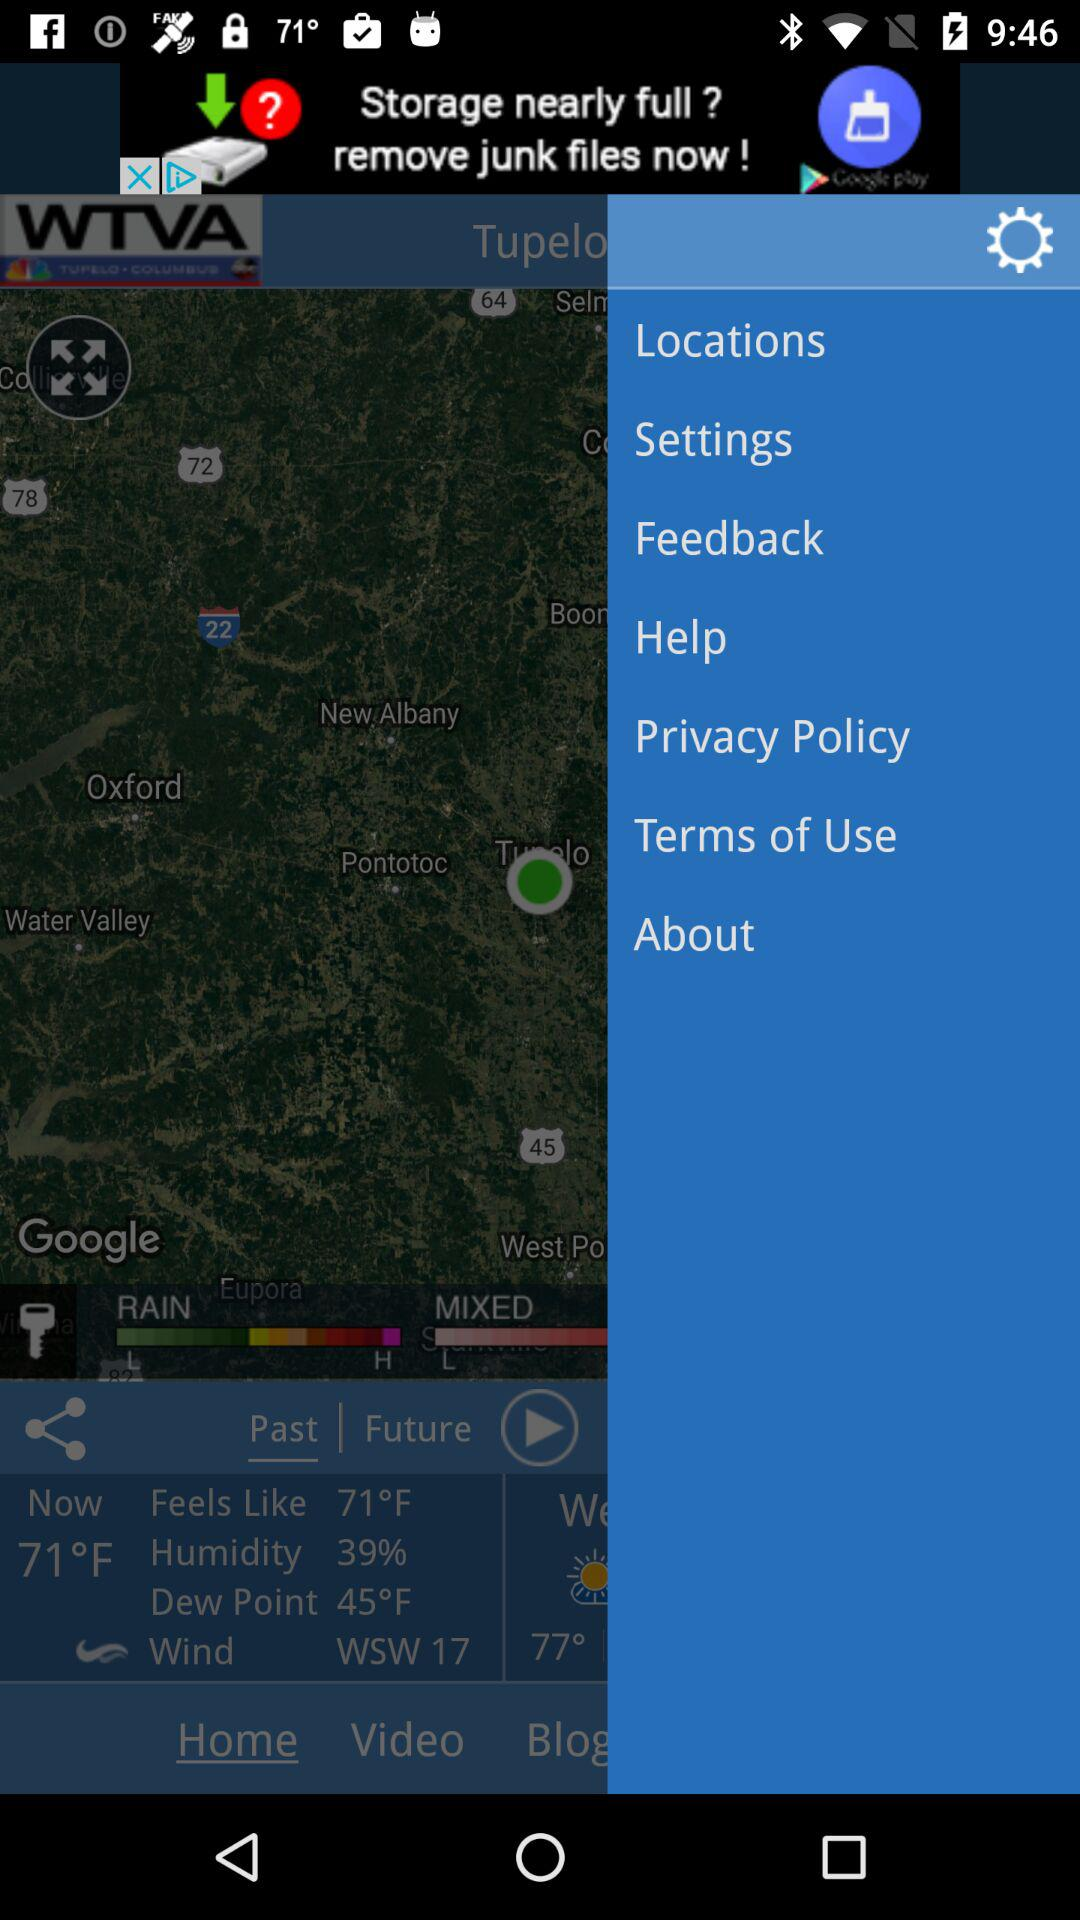How many more degrees is the temperature than the dew point?
Answer the question using a single word or phrase. 26 